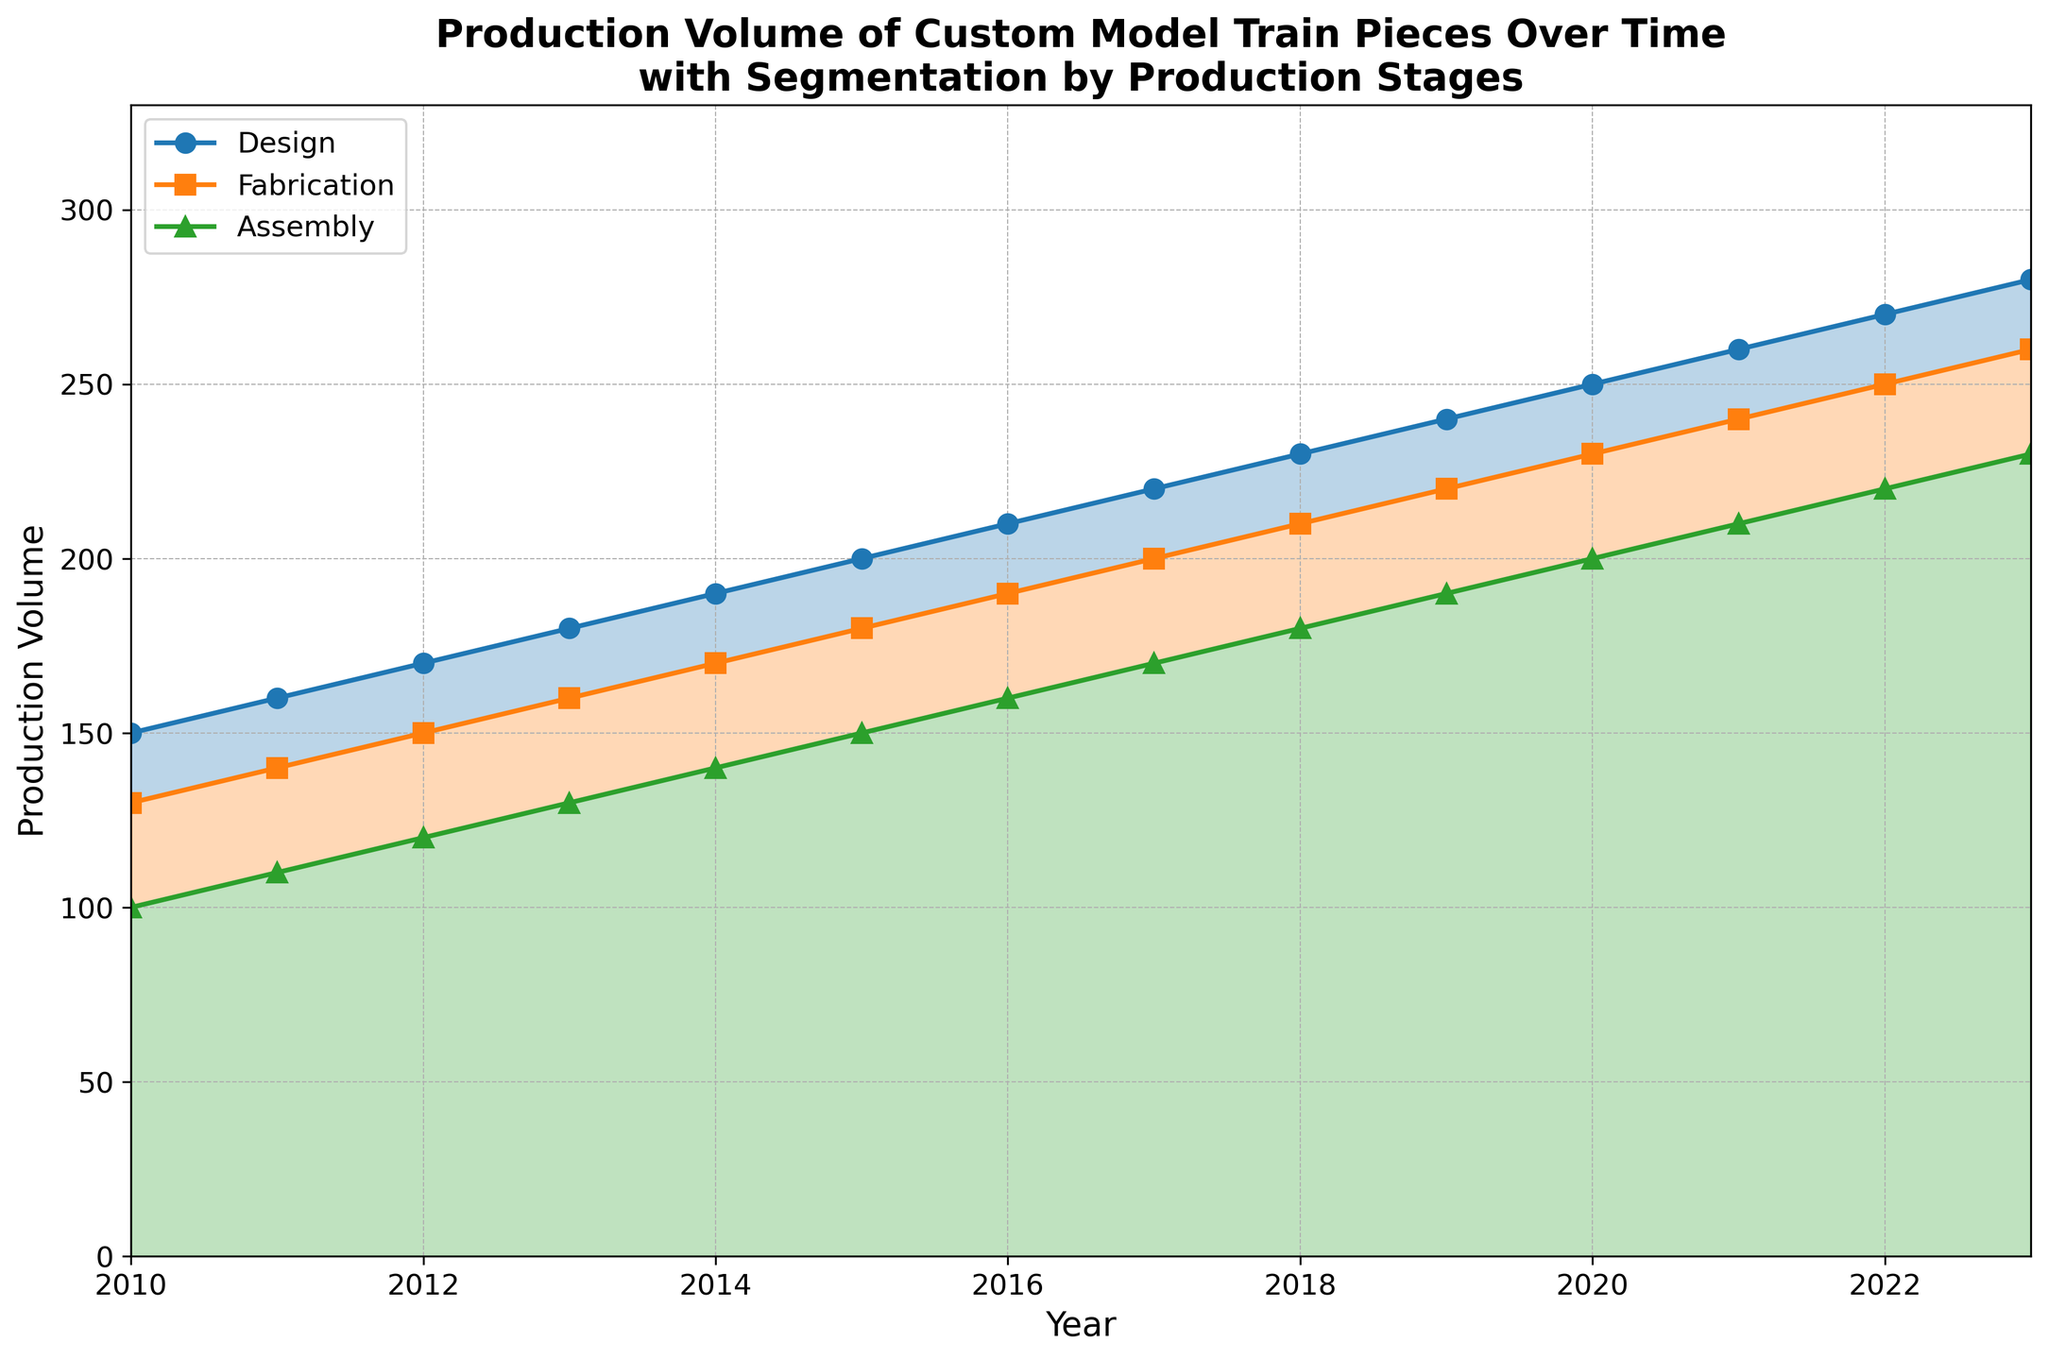What was the production volume in the design stage in 2015? The production volume for the design stage in 2015 can be read directly from the chart. It corresponds to a y-axis value of 200 for the design stage for the year 2015.
Answer: 200 When was the first year that the assembly stage production volume exceeded 130? To determine this, locate the segment of the assembly stage line and find the first year where its volume surpasses 130 on the y-axis. That year is 2016.
Answer: 2016 What is the difference in production volume between the fabrication and assembly stages in the year 2020? The production volume for fabrication in 2020 is 230, while for assembly, it is 200. The difference is 230 - 200 = 30.
Answer: 30 Between which years did the design stage see the highest increase in production volume? To find this, look at the design stage line and identify the segment with the steepest upward slope. The largest single-year increase in the design stage is from 2012 (170) to 2013 (180), which is an increase of 10.
Answer: 2012 to 2013 In 2018, which production stage had the lowest production volume, and what was it? For 2018, look at the y-axis values for each stage. The assembly stage has the lowest volume in 2018, which is 180.
Answer: Assembly, 180 How much did the production volume in the assembly stage increase from 2010 to 2023? The production volume for the assembly stage in 2010 was 100, and in 2023 it was 230. The increase is 230 - 100 = 130.
Answer: 130 Is there any year where the production volume in all three stages is equal? By examining the lines, we can see that no single year has production volumes that are all equal across the three stages.
Answer: No Calculate the average production volume for the fabrication stage over the years 2015 to 2020. Sum the fabrication volumes from 2015 to 2020: 180 + 190 + 200 + 210 + 220 + 230 = 1230. Divide by the number of years: 1230 / 6 = 205.
Answer: 205 Which stage had the largest range (difference between maximum and minimum values) in production volume over the shown years? Calculate the range for each stage. Design: 280 - 150 = 130, Fabrication: 260 - 130 = 130, Assembly: 230 - 100 = 130. All stages have the same range.
Answer: All stages What trend can be observed in the overall production volume of custom model train pieces from 2010 to 2023? Observe the general progression of the lines. There is a consistent upward trend in the production volume for all three stages from 2010 to 2023.
Answer: Upward trend 